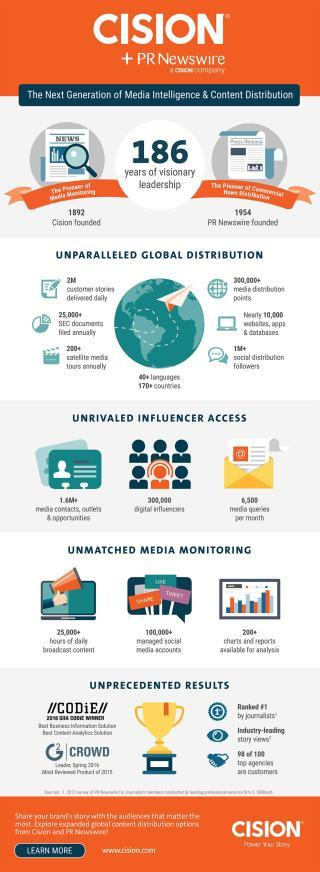Outline some significant characteristics in this image. The Cision PR Newswire Company provided over 200 charts and reports for analysis in its unmatched media monitoring service. The Cision PR Newswire Company manages over 100,000+ social media accounts globally. The Cision PR Newswire company had daily broadcasts with over 25,000 hours of content available. PR Newswire was founded in 1954. The Cision PR Newswire company has over 1 million social distribution followers globally. 